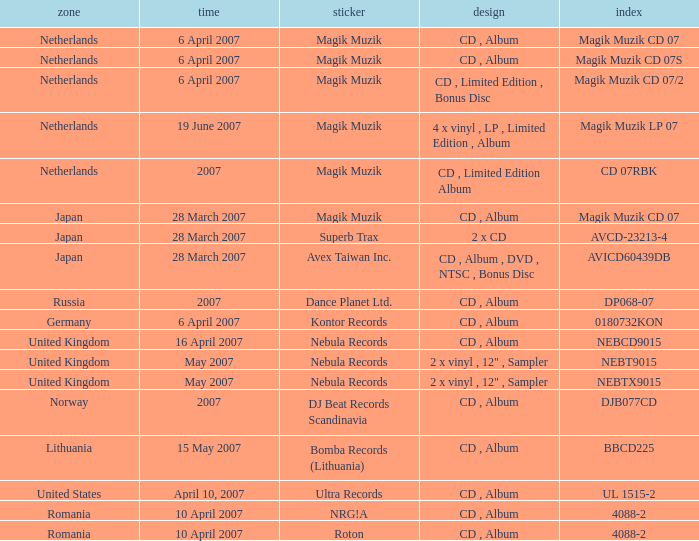Which label released the catalog Magik Muzik CD 07 on 28 March 2007? Magik Muzik. 